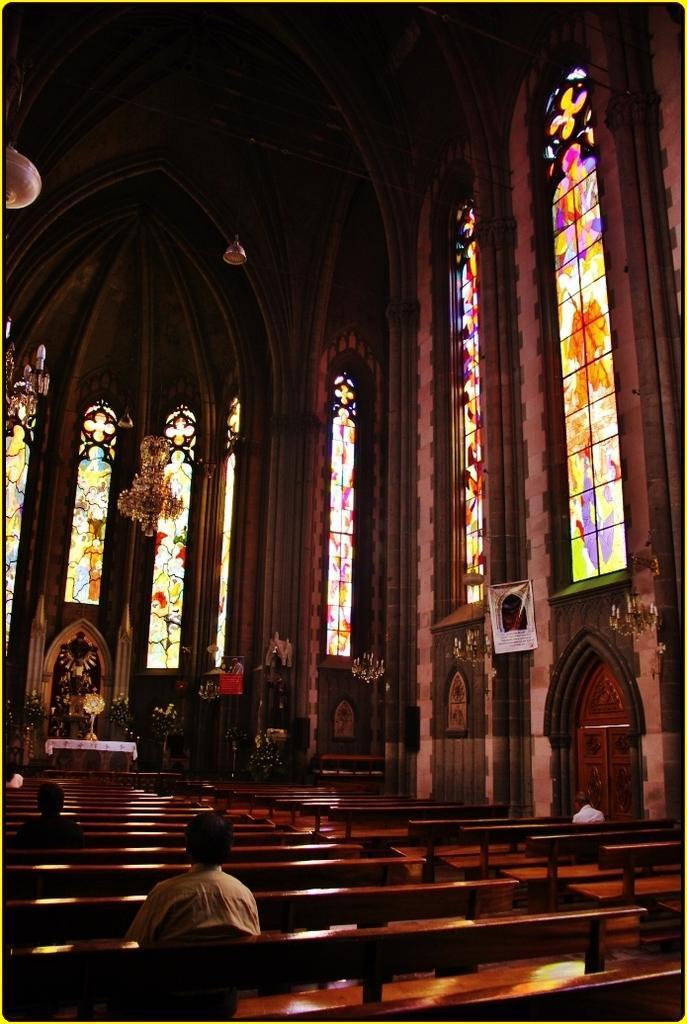Describe this image in one or two sentences. In this picture I can see few people sitting on the benches and I can see a statue and lights to the ceiling and I can see designer glasses to the windows. 